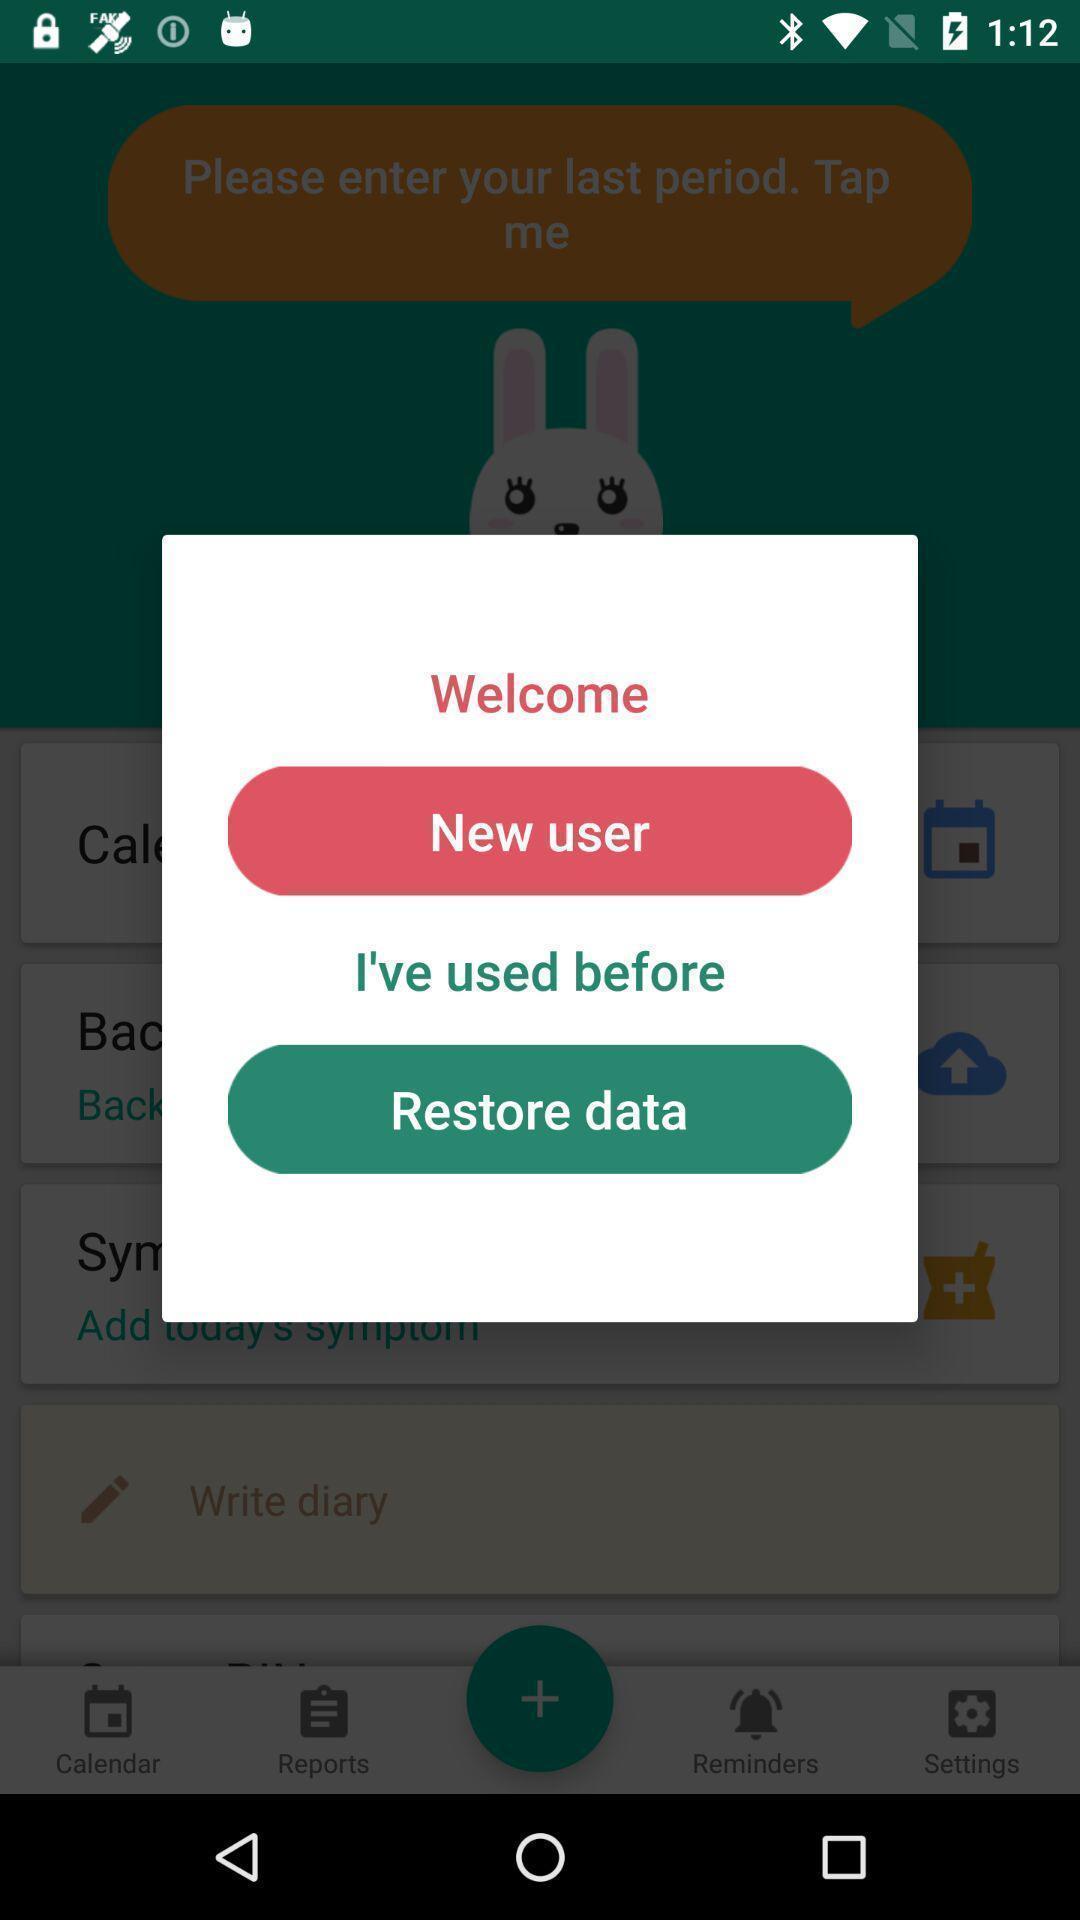What details can you identify in this image? Welcome page. 